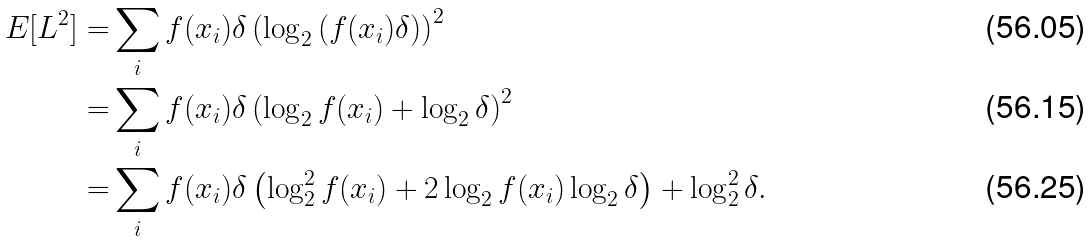<formula> <loc_0><loc_0><loc_500><loc_500>E [ L ^ { 2 } ] = & \sum _ { i } f ( x _ { i } ) \delta \left ( \log _ { 2 } { \left ( f ( x _ { i } ) \delta \right ) } \right ) ^ { 2 } \\ = & \sum _ { i } f ( x _ { i } ) \delta \left ( \log _ { 2 } { f ( x _ { i } ) } + \log _ { 2 } { \delta } \right ) ^ { 2 } \\ = & \sum _ { i } f ( x _ { i } ) \delta \left ( \log _ { 2 } ^ { 2 } { f ( x _ { i } ) } + 2 \log _ { 2 } { f ( x _ { i } ) } \log _ { 2 } { \delta } \right ) + \log _ { 2 } ^ { 2 } { \delta } .</formula> 